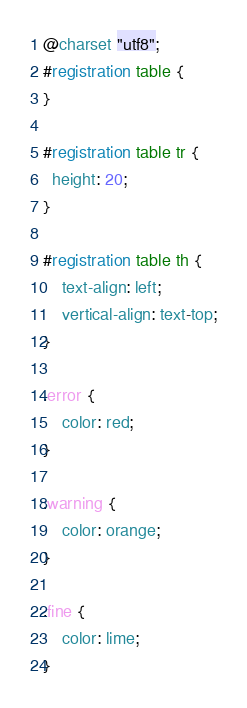Convert code to text. <code><loc_0><loc_0><loc_500><loc_500><_CSS_>@charset "utf8";
#registration table {
}

#registration table tr {
  height: 20;
}

#registration table th {
    text-align: left;
    vertical-align: text-top;
}

.error {
	color: red;
}

.warning {
	color: orange;
}

.fine {
	color: lime;
}</code> 